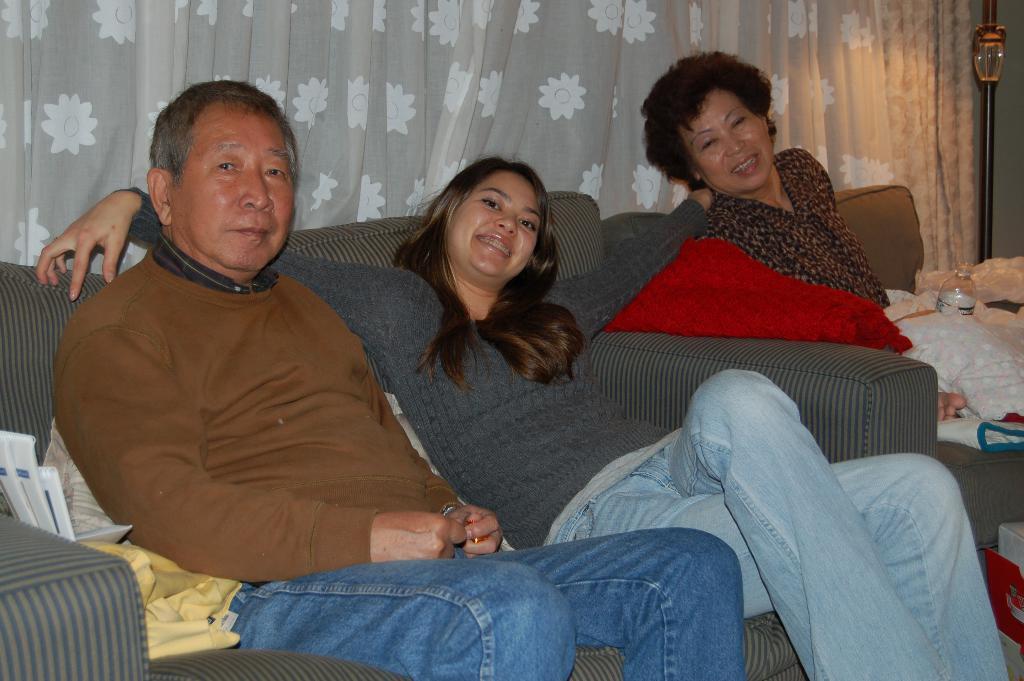How would you summarize this image in a sentence or two? This picture is clicked inside the room. Here, we see three people sitting on sofa. On the left corner of the picture, man wearing brown t-shirt and blue jeans is sitting behind the girl wearing grey t-shirt and she is laughing. Beside her, we see a red bed sheet and in front of a woman wearing black shirt, we see white cloth and water bottle and behind them we see curtain which is white in color. 